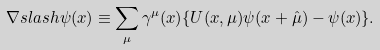Convert formula to latex. <formula><loc_0><loc_0><loc_500><loc_500>\nabla s l a s h \psi ( x ) \equiv \sum _ { \mu } \gamma ^ { \mu } ( x ) \{ U ( x , \mu ) \psi ( x + \hat { \mu } ) - \psi ( x ) \} .</formula> 